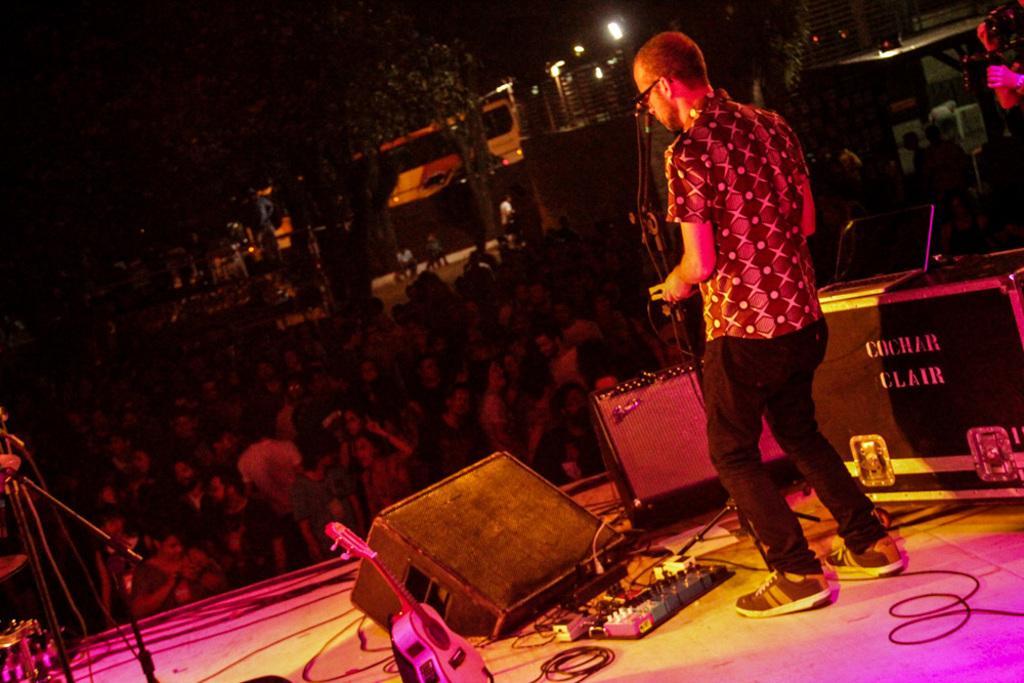Could you give a brief overview of what you see in this image? In this picture there is a man who is standing near to the mic. In front of him we can see the speakers, guitar, cable, socket, musical instruments and other objects. In front of the stage we can see the group of persons were dancing. In the background there is a bus which is parked near to the trees and lights. On the top right corner there is a man who is holding a camera. 